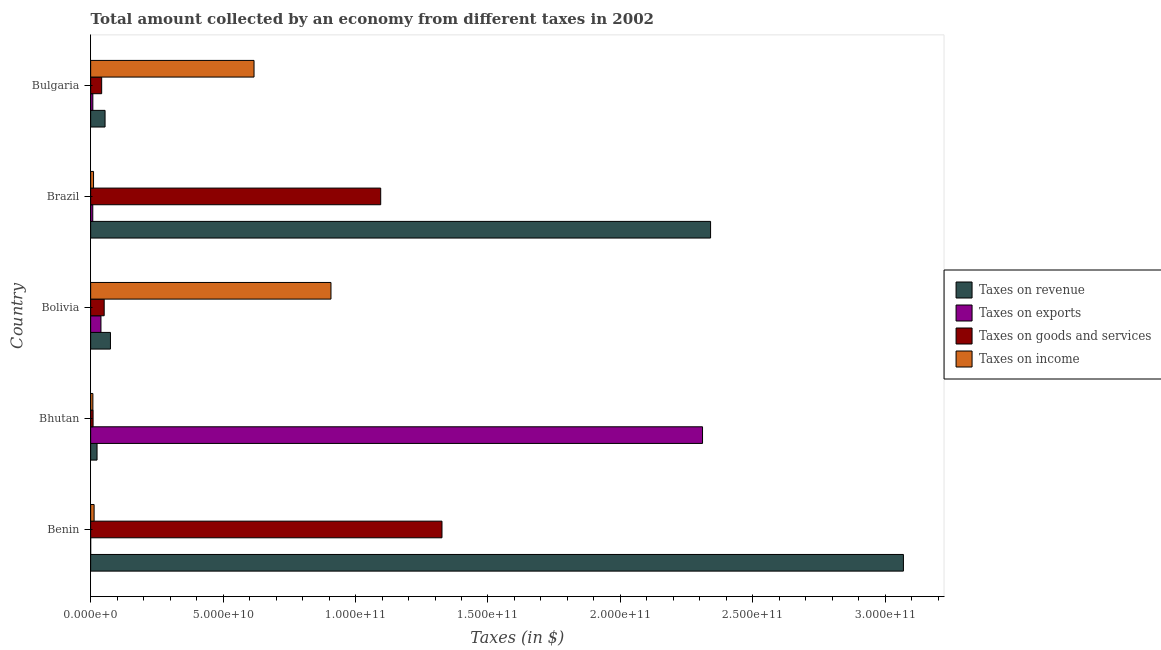How many different coloured bars are there?
Give a very brief answer. 4. How many groups of bars are there?
Your answer should be compact. 5. Are the number of bars on each tick of the Y-axis equal?
Make the answer very short. Yes. How many bars are there on the 1st tick from the top?
Keep it short and to the point. 4. What is the amount collected as tax on goods in Bhutan?
Provide a succinct answer. 9.15e+08. Across all countries, what is the maximum amount collected as tax on revenue?
Your answer should be very brief. 3.07e+11. Across all countries, what is the minimum amount collected as tax on exports?
Your answer should be compact. 6.36e+05. In which country was the amount collected as tax on revenue maximum?
Offer a very short reply. Benin. In which country was the amount collected as tax on revenue minimum?
Your answer should be compact. Bhutan. What is the total amount collected as tax on goods in the graph?
Your answer should be very brief. 2.52e+11. What is the difference between the amount collected as tax on goods in Benin and that in Brazil?
Offer a very short reply. 2.31e+1. What is the difference between the amount collected as tax on goods in Bulgaria and the amount collected as tax on revenue in Benin?
Provide a short and direct response. -3.03e+11. What is the average amount collected as tax on exports per country?
Make the answer very short. 4.73e+1. What is the difference between the amount collected as tax on income and amount collected as tax on goods in Bhutan?
Make the answer very short. -7.36e+07. In how many countries, is the amount collected as tax on income greater than 200000000000 $?
Offer a terse response. 0. What is the ratio of the amount collected as tax on exports in Bhutan to that in Bolivia?
Your response must be concise. 59.46. What is the difference between the highest and the second highest amount collected as tax on revenue?
Provide a succinct answer. 7.28e+1. What is the difference between the highest and the lowest amount collected as tax on revenue?
Your response must be concise. 3.04e+11. In how many countries, is the amount collected as tax on income greater than the average amount collected as tax on income taken over all countries?
Your answer should be compact. 2. What does the 1st bar from the top in Bolivia represents?
Ensure brevity in your answer.  Taxes on income. What does the 2nd bar from the bottom in Brazil represents?
Offer a very short reply. Taxes on exports. Is it the case that in every country, the sum of the amount collected as tax on revenue and amount collected as tax on exports is greater than the amount collected as tax on goods?
Your answer should be very brief. Yes. Are all the bars in the graph horizontal?
Keep it short and to the point. Yes. What is the difference between two consecutive major ticks on the X-axis?
Provide a succinct answer. 5.00e+1. Does the graph contain grids?
Make the answer very short. No. How many legend labels are there?
Your answer should be very brief. 4. What is the title of the graph?
Make the answer very short. Total amount collected by an economy from different taxes in 2002. Does "Periodicity assessment" appear as one of the legend labels in the graph?
Your answer should be compact. No. What is the label or title of the X-axis?
Offer a very short reply. Taxes (in $). What is the label or title of the Y-axis?
Your answer should be compact. Country. What is the Taxes (in $) of Taxes on revenue in Benin?
Provide a short and direct response. 3.07e+11. What is the Taxes (in $) of Taxes on exports in Benin?
Keep it short and to the point. 6.36e+05. What is the Taxes (in $) in Taxes on goods and services in Benin?
Provide a short and direct response. 1.33e+11. What is the Taxes (in $) in Taxes on income in Benin?
Your answer should be compact. 1.31e+09. What is the Taxes (in $) in Taxes on revenue in Bhutan?
Keep it short and to the point. 2.41e+09. What is the Taxes (in $) in Taxes on exports in Bhutan?
Provide a short and direct response. 2.31e+11. What is the Taxes (in $) of Taxes on goods and services in Bhutan?
Your answer should be very brief. 9.15e+08. What is the Taxes (in $) of Taxes on income in Bhutan?
Make the answer very short. 8.41e+08. What is the Taxes (in $) in Taxes on revenue in Bolivia?
Give a very brief answer. 7.47e+09. What is the Taxes (in $) in Taxes on exports in Bolivia?
Provide a short and direct response. 3.89e+09. What is the Taxes (in $) of Taxes on goods and services in Bolivia?
Offer a very short reply. 5.11e+09. What is the Taxes (in $) of Taxes on income in Bolivia?
Your response must be concise. 9.07e+1. What is the Taxes (in $) in Taxes on revenue in Brazil?
Keep it short and to the point. 2.34e+11. What is the Taxes (in $) in Taxes on exports in Brazil?
Give a very brief answer. 8.03e+08. What is the Taxes (in $) in Taxes on goods and services in Brazil?
Keep it short and to the point. 1.10e+11. What is the Taxes (in $) in Taxes on income in Brazil?
Your answer should be very brief. 1.09e+09. What is the Taxes (in $) in Taxes on revenue in Bulgaria?
Make the answer very short. 5.44e+09. What is the Taxes (in $) in Taxes on exports in Bulgaria?
Keep it short and to the point. 8.25e+08. What is the Taxes (in $) in Taxes on goods and services in Bulgaria?
Your answer should be very brief. 4.16e+09. What is the Taxes (in $) of Taxes on income in Bulgaria?
Your response must be concise. 6.17e+1. Across all countries, what is the maximum Taxes (in $) in Taxes on revenue?
Your answer should be compact. 3.07e+11. Across all countries, what is the maximum Taxes (in $) in Taxes on exports?
Offer a terse response. 2.31e+11. Across all countries, what is the maximum Taxes (in $) in Taxes on goods and services?
Give a very brief answer. 1.33e+11. Across all countries, what is the maximum Taxes (in $) in Taxes on income?
Give a very brief answer. 9.07e+1. Across all countries, what is the minimum Taxes (in $) in Taxes on revenue?
Your response must be concise. 2.41e+09. Across all countries, what is the minimum Taxes (in $) in Taxes on exports?
Your answer should be compact. 6.36e+05. Across all countries, what is the minimum Taxes (in $) in Taxes on goods and services?
Make the answer very short. 9.15e+08. Across all countries, what is the minimum Taxes (in $) in Taxes on income?
Your answer should be compact. 8.41e+08. What is the total Taxes (in $) of Taxes on revenue in the graph?
Make the answer very short. 5.56e+11. What is the total Taxes (in $) of Taxes on exports in the graph?
Provide a short and direct response. 2.37e+11. What is the total Taxes (in $) in Taxes on goods and services in the graph?
Your answer should be very brief. 2.52e+11. What is the total Taxes (in $) in Taxes on income in the graph?
Offer a terse response. 1.56e+11. What is the difference between the Taxes (in $) of Taxes on revenue in Benin and that in Bhutan?
Provide a short and direct response. 3.04e+11. What is the difference between the Taxes (in $) of Taxes on exports in Benin and that in Bhutan?
Make the answer very short. -2.31e+11. What is the difference between the Taxes (in $) of Taxes on goods and services in Benin and that in Bhutan?
Provide a succinct answer. 1.32e+11. What is the difference between the Taxes (in $) in Taxes on income in Benin and that in Bhutan?
Give a very brief answer. 4.64e+08. What is the difference between the Taxes (in $) of Taxes on revenue in Benin and that in Bolivia?
Ensure brevity in your answer.  2.99e+11. What is the difference between the Taxes (in $) in Taxes on exports in Benin and that in Bolivia?
Keep it short and to the point. -3.88e+09. What is the difference between the Taxes (in $) in Taxes on goods and services in Benin and that in Bolivia?
Make the answer very short. 1.28e+11. What is the difference between the Taxes (in $) of Taxes on income in Benin and that in Bolivia?
Your answer should be compact. -8.94e+1. What is the difference between the Taxes (in $) in Taxes on revenue in Benin and that in Brazil?
Offer a terse response. 7.28e+1. What is the difference between the Taxes (in $) in Taxes on exports in Benin and that in Brazil?
Provide a succinct answer. -8.02e+08. What is the difference between the Taxes (in $) of Taxes on goods and services in Benin and that in Brazil?
Provide a succinct answer. 2.31e+1. What is the difference between the Taxes (in $) in Taxes on income in Benin and that in Brazil?
Ensure brevity in your answer.  2.17e+08. What is the difference between the Taxes (in $) in Taxes on revenue in Benin and that in Bulgaria?
Keep it short and to the point. 3.01e+11. What is the difference between the Taxes (in $) of Taxes on exports in Benin and that in Bulgaria?
Your response must be concise. -8.25e+08. What is the difference between the Taxes (in $) in Taxes on goods and services in Benin and that in Bulgaria?
Make the answer very short. 1.28e+11. What is the difference between the Taxes (in $) in Taxes on income in Benin and that in Bulgaria?
Your response must be concise. -6.04e+1. What is the difference between the Taxes (in $) in Taxes on revenue in Bhutan and that in Bolivia?
Provide a short and direct response. -5.06e+09. What is the difference between the Taxes (in $) in Taxes on exports in Bhutan and that in Bolivia?
Make the answer very short. 2.27e+11. What is the difference between the Taxes (in $) of Taxes on goods and services in Bhutan and that in Bolivia?
Your answer should be compact. -4.19e+09. What is the difference between the Taxes (in $) in Taxes on income in Bhutan and that in Bolivia?
Offer a very short reply. -8.99e+1. What is the difference between the Taxes (in $) of Taxes on revenue in Bhutan and that in Brazil?
Your response must be concise. -2.32e+11. What is the difference between the Taxes (in $) of Taxes on exports in Bhutan and that in Brazil?
Your answer should be compact. 2.30e+11. What is the difference between the Taxes (in $) of Taxes on goods and services in Bhutan and that in Brazil?
Your answer should be very brief. -1.09e+11. What is the difference between the Taxes (in $) in Taxes on income in Bhutan and that in Brazil?
Your response must be concise. -2.47e+08. What is the difference between the Taxes (in $) in Taxes on revenue in Bhutan and that in Bulgaria?
Your response must be concise. -3.02e+09. What is the difference between the Taxes (in $) in Taxes on exports in Bhutan and that in Bulgaria?
Your response must be concise. 2.30e+11. What is the difference between the Taxes (in $) of Taxes on goods and services in Bhutan and that in Bulgaria?
Offer a terse response. -3.24e+09. What is the difference between the Taxes (in $) of Taxes on income in Bhutan and that in Bulgaria?
Your answer should be very brief. -6.08e+1. What is the difference between the Taxes (in $) in Taxes on revenue in Bolivia and that in Brazil?
Offer a terse response. -2.27e+11. What is the difference between the Taxes (in $) in Taxes on exports in Bolivia and that in Brazil?
Offer a terse response. 3.08e+09. What is the difference between the Taxes (in $) of Taxes on goods and services in Bolivia and that in Brazil?
Provide a short and direct response. -1.04e+11. What is the difference between the Taxes (in $) in Taxes on income in Bolivia and that in Brazil?
Keep it short and to the point. 8.96e+1. What is the difference between the Taxes (in $) of Taxes on revenue in Bolivia and that in Bulgaria?
Ensure brevity in your answer.  2.03e+09. What is the difference between the Taxes (in $) in Taxes on exports in Bolivia and that in Bulgaria?
Keep it short and to the point. 3.06e+09. What is the difference between the Taxes (in $) of Taxes on goods and services in Bolivia and that in Bulgaria?
Your answer should be compact. 9.51e+08. What is the difference between the Taxes (in $) in Taxes on income in Bolivia and that in Bulgaria?
Give a very brief answer. 2.90e+1. What is the difference between the Taxes (in $) of Taxes on revenue in Brazil and that in Bulgaria?
Offer a very short reply. 2.29e+11. What is the difference between the Taxes (in $) in Taxes on exports in Brazil and that in Bulgaria?
Give a very brief answer. -2.22e+07. What is the difference between the Taxes (in $) of Taxes on goods and services in Brazil and that in Bulgaria?
Make the answer very short. 1.05e+11. What is the difference between the Taxes (in $) of Taxes on income in Brazil and that in Bulgaria?
Your response must be concise. -6.06e+1. What is the difference between the Taxes (in $) of Taxes on revenue in Benin and the Taxes (in $) of Taxes on exports in Bhutan?
Your response must be concise. 7.58e+1. What is the difference between the Taxes (in $) in Taxes on revenue in Benin and the Taxes (in $) in Taxes on goods and services in Bhutan?
Your answer should be compact. 3.06e+11. What is the difference between the Taxes (in $) in Taxes on revenue in Benin and the Taxes (in $) in Taxes on income in Bhutan?
Provide a short and direct response. 3.06e+11. What is the difference between the Taxes (in $) of Taxes on exports in Benin and the Taxes (in $) of Taxes on goods and services in Bhutan?
Keep it short and to the point. -9.14e+08. What is the difference between the Taxes (in $) in Taxes on exports in Benin and the Taxes (in $) in Taxes on income in Bhutan?
Your answer should be compact. -8.41e+08. What is the difference between the Taxes (in $) of Taxes on goods and services in Benin and the Taxes (in $) of Taxes on income in Bhutan?
Keep it short and to the point. 1.32e+11. What is the difference between the Taxes (in $) in Taxes on revenue in Benin and the Taxes (in $) in Taxes on exports in Bolivia?
Ensure brevity in your answer.  3.03e+11. What is the difference between the Taxes (in $) in Taxes on revenue in Benin and the Taxes (in $) in Taxes on goods and services in Bolivia?
Ensure brevity in your answer.  3.02e+11. What is the difference between the Taxes (in $) in Taxes on revenue in Benin and the Taxes (in $) in Taxes on income in Bolivia?
Your response must be concise. 2.16e+11. What is the difference between the Taxes (in $) in Taxes on exports in Benin and the Taxes (in $) in Taxes on goods and services in Bolivia?
Provide a succinct answer. -5.11e+09. What is the difference between the Taxes (in $) in Taxes on exports in Benin and the Taxes (in $) in Taxes on income in Bolivia?
Provide a short and direct response. -9.07e+1. What is the difference between the Taxes (in $) of Taxes on goods and services in Benin and the Taxes (in $) of Taxes on income in Bolivia?
Offer a terse response. 4.19e+1. What is the difference between the Taxes (in $) of Taxes on revenue in Benin and the Taxes (in $) of Taxes on exports in Brazil?
Offer a very short reply. 3.06e+11. What is the difference between the Taxes (in $) in Taxes on revenue in Benin and the Taxes (in $) in Taxes on goods and services in Brazil?
Offer a very short reply. 1.97e+11. What is the difference between the Taxes (in $) in Taxes on revenue in Benin and the Taxes (in $) in Taxes on income in Brazil?
Your response must be concise. 3.06e+11. What is the difference between the Taxes (in $) of Taxes on exports in Benin and the Taxes (in $) of Taxes on goods and services in Brazil?
Offer a very short reply. -1.10e+11. What is the difference between the Taxes (in $) in Taxes on exports in Benin and the Taxes (in $) in Taxes on income in Brazil?
Your response must be concise. -1.09e+09. What is the difference between the Taxes (in $) of Taxes on goods and services in Benin and the Taxes (in $) of Taxes on income in Brazil?
Provide a short and direct response. 1.32e+11. What is the difference between the Taxes (in $) of Taxes on revenue in Benin and the Taxes (in $) of Taxes on exports in Bulgaria?
Give a very brief answer. 3.06e+11. What is the difference between the Taxes (in $) of Taxes on revenue in Benin and the Taxes (in $) of Taxes on goods and services in Bulgaria?
Keep it short and to the point. 3.03e+11. What is the difference between the Taxes (in $) of Taxes on revenue in Benin and the Taxes (in $) of Taxes on income in Bulgaria?
Ensure brevity in your answer.  2.45e+11. What is the difference between the Taxes (in $) in Taxes on exports in Benin and the Taxes (in $) in Taxes on goods and services in Bulgaria?
Your answer should be very brief. -4.16e+09. What is the difference between the Taxes (in $) in Taxes on exports in Benin and the Taxes (in $) in Taxes on income in Bulgaria?
Ensure brevity in your answer.  -6.17e+1. What is the difference between the Taxes (in $) in Taxes on goods and services in Benin and the Taxes (in $) in Taxes on income in Bulgaria?
Provide a succinct answer. 7.10e+1. What is the difference between the Taxes (in $) in Taxes on revenue in Bhutan and the Taxes (in $) in Taxes on exports in Bolivia?
Your answer should be compact. -1.47e+09. What is the difference between the Taxes (in $) in Taxes on revenue in Bhutan and the Taxes (in $) in Taxes on goods and services in Bolivia?
Keep it short and to the point. -2.69e+09. What is the difference between the Taxes (in $) in Taxes on revenue in Bhutan and the Taxes (in $) in Taxes on income in Bolivia?
Offer a terse response. -8.83e+1. What is the difference between the Taxes (in $) of Taxes on exports in Bhutan and the Taxes (in $) of Taxes on goods and services in Bolivia?
Your answer should be compact. 2.26e+11. What is the difference between the Taxes (in $) in Taxes on exports in Bhutan and the Taxes (in $) in Taxes on income in Bolivia?
Keep it short and to the point. 1.40e+11. What is the difference between the Taxes (in $) of Taxes on goods and services in Bhutan and the Taxes (in $) of Taxes on income in Bolivia?
Ensure brevity in your answer.  -8.98e+1. What is the difference between the Taxes (in $) of Taxes on revenue in Bhutan and the Taxes (in $) of Taxes on exports in Brazil?
Make the answer very short. 1.61e+09. What is the difference between the Taxes (in $) in Taxes on revenue in Bhutan and the Taxes (in $) in Taxes on goods and services in Brazil?
Your answer should be very brief. -1.07e+11. What is the difference between the Taxes (in $) of Taxes on revenue in Bhutan and the Taxes (in $) of Taxes on income in Brazil?
Ensure brevity in your answer.  1.33e+09. What is the difference between the Taxes (in $) of Taxes on exports in Bhutan and the Taxes (in $) of Taxes on goods and services in Brazil?
Your response must be concise. 1.21e+11. What is the difference between the Taxes (in $) of Taxes on exports in Bhutan and the Taxes (in $) of Taxes on income in Brazil?
Your answer should be very brief. 2.30e+11. What is the difference between the Taxes (in $) in Taxes on goods and services in Bhutan and the Taxes (in $) in Taxes on income in Brazil?
Ensure brevity in your answer.  -1.73e+08. What is the difference between the Taxes (in $) of Taxes on revenue in Bhutan and the Taxes (in $) of Taxes on exports in Bulgaria?
Your response must be concise. 1.59e+09. What is the difference between the Taxes (in $) of Taxes on revenue in Bhutan and the Taxes (in $) of Taxes on goods and services in Bulgaria?
Your answer should be very brief. -1.74e+09. What is the difference between the Taxes (in $) in Taxes on revenue in Bhutan and the Taxes (in $) in Taxes on income in Bulgaria?
Your answer should be compact. -5.93e+1. What is the difference between the Taxes (in $) in Taxes on exports in Bhutan and the Taxes (in $) in Taxes on goods and services in Bulgaria?
Your answer should be compact. 2.27e+11. What is the difference between the Taxes (in $) in Taxes on exports in Bhutan and the Taxes (in $) in Taxes on income in Bulgaria?
Offer a terse response. 1.69e+11. What is the difference between the Taxes (in $) of Taxes on goods and services in Bhutan and the Taxes (in $) of Taxes on income in Bulgaria?
Make the answer very short. -6.08e+1. What is the difference between the Taxes (in $) of Taxes on revenue in Bolivia and the Taxes (in $) of Taxes on exports in Brazil?
Provide a succinct answer. 6.67e+09. What is the difference between the Taxes (in $) of Taxes on revenue in Bolivia and the Taxes (in $) of Taxes on goods and services in Brazil?
Ensure brevity in your answer.  -1.02e+11. What is the difference between the Taxes (in $) in Taxes on revenue in Bolivia and the Taxes (in $) in Taxes on income in Brazil?
Provide a short and direct response. 6.38e+09. What is the difference between the Taxes (in $) of Taxes on exports in Bolivia and the Taxes (in $) of Taxes on goods and services in Brazil?
Your answer should be very brief. -1.06e+11. What is the difference between the Taxes (in $) in Taxes on exports in Bolivia and the Taxes (in $) in Taxes on income in Brazil?
Offer a terse response. 2.80e+09. What is the difference between the Taxes (in $) of Taxes on goods and services in Bolivia and the Taxes (in $) of Taxes on income in Brazil?
Your answer should be compact. 4.02e+09. What is the difference between the Taxes (in $) in Taxes on revenue in Bolivia and the Taxes (in $) in Taxes on exports in Bulgaria?
Give a very brief answer. 6.65e+09. What is the difference between the Taxes (in $) of Taxes on revenue in Bolivia and the Taxes (in $) of Taxes on goods and services in Bulgaria?
Offer a very short reply. 3.31e+09. What is the difference between the Taxes (in $) of Taxes on revenue in Bolivia and the Taxes (in $) of Taxes on income in Bulgaria?
Offer a very short reply. -5.42e+1. What is the difference between the Taxes (in $) of Taxes on exports in Bolivia and the Taxes (in $) of Taxes on goods and services in Bulgaria?
Provide a short and direct response. -2.74e+08. What is the difference between the Taxes (in $) in Taxes on exports in Bolivia and the Taxes (in $) in Taxes on income in Bulgaria?
Your answer should be very brief. -5.78e+1. What is the difference between the Taxes (in $) of Taxes on goods and services in Bolivia and the Taxes (in $) of Taxes on income in Bulgaria?
Provide a short and direct response. -5.66e+1. What is the difference between the Taxes (in $) of Taxes on revenue in Brazil and the Taxes (in $) of Taxes on exports in Bulgaria?
Your answer should be very brief. 2.33e+11. What is the difference between the Taxes (in $) of Taxes on revenue in Brazil and the Taxes (in $) of Taxes on goods and services in Bulgaria?
Your answer should be very brief. 2.30e+11. What is the difference between the Taxes (in $) in Taxes on revenue in Brazil and the Taxes (in $) in Taxes on income in Bulgaria?
Offer a terse response. 1.72e+11. What is the difference between the Taxes (in $) in Taxes on exports in Brazil and the Taxes (in $) in Taxes on goods and services in Bulgaria?
Offer a very short reply. -3.36e+09. What is the difference between the Taxes (in $) of Taxes on exports in Brazil and the Taxes (in $) of Taxes on income in Bulgaria?
Offer a terse response. -6.09e+1. What is the difference between the Taxes (in $) in Taxes on goods and services in Brazil and the Taxes (in $) in Taxes on income in Bulgaria?
Make the answer very short. 4.78e+1. What is the average Taxes (in $) in Taxes on revenue per country?
Offer a very short reply. 1.11e+11. What is the average Taxes (in $) in Taxes on exports per country?
Your answer should be compact. 4.73e+1. What is the average Taxes (in $) of Taxes on goods and services per country?
Your answer should be very brief. 5.05e+1. What is the average Taxes (in $) in Taxes on income per country?
Your answer should be very brief. 3.11e+1. What is the difference between the Taxes (in $) of Taxes on revenue and Taxes (in $) of Taxes on exports in Benin?
Give a very brief answer. 3.07e+11. What is the difference between the Taxes (in $) in Taxes on revenue and Taxes (in $) in Taxes on goods and services in Benin?
Ensure brevity in your answer.  1.74e+11. What is the difference between the Taxes (in $) of Taxes on revenue and Taxes (in $) of Taxes on income in Benin?
Ensure brevity in your answer.  3.06e+11. What is the difference between the Taxes (in $) in Taxes on exports and Taxes (in $) in Taxes on goods and services in Benin?
Offer a terse response. -1.33e+11. What is the difference between the Taxes (in $) of Taxes on exports and Taxes (in $) of Taxes on income in Benin?
Your answer should be compact. -1.30e+09. What is the difference between the Taxes (in $) in Taxes on goods and services and Taxes (in $) in Taxes on income in Benin?
Give a very brief answer. 1.31e+11. What is the difference between the Taxes (in $) in Taxes on revenue and Taxes (in $) in Taxes on exports in Bhutan?
Keep it short and to the point. -2.29e+11. What is the difference between the Taxes (in $) of Taxes on revenue and Taxes (in $) of Taxes on goods and services in Bhutan?
Give a very brief answer. 1.50e+09. What is the difference between the Taxes (in $) in Taxes on revenue and Taxes (in $) in Taxes on income in Bhutan?
Your answer should be compact. 1.57e+09. What is the difference between the Taxes (in $) of Taxes on exports and Taxes (in $) of Taxes on goods and services in Bhutan?
Your answer should be compact. 2.30e+11. What is the difference between the Taxes (in $) in Taxes on exports and Taxes (in $) in Taxes on income in Bhutan?
Give a very brief answer. 2.30e+11. What is the difference between the Taxes (in $) in Taxes on goods and services and Taxes (in $) in Taxes on income in Bhutan?
Provide a succinct answer. 7.36e+07. What is the difference between the Taxes (in $) of Taxes on revenue and Taxes (in $) of Taxes on exports in Bolivia?
Make the answer very short. 3.59e+09. What is the difference between the Taxes (in $) of Taxes on revenue and Taxes (in $) of Taxes on goods and services in Bolivia?
Your answer should be very brief. 2.36e+09. What is the difference between the Taxes (in $) of Taxes on revenue and Taxes (in $) of Taxes on income in Bolivia?
Offer a terse response. -8.33e+1. What is the difference between the Taxes (in $) of Taxes on exports and Taxes (in $) of Taxes on goods and services in Bolivia?
Your answer should be very brief. -1.22e+09. What is the difference between the Taxes (in $) of Taxes on exports and Taxes (in $) of Taxes on income in Bolivia?
Your response must be concise. -8.68e+1. What is the difference between the Taxes (in $) of Taxes on goods and services and Taxes (in $) of Taxes on income in Bolivia?
Provide a succinct answer. -8.56e+1. What is the difference between the Taxes (in $) in Taxes on revenue and Taxes (in $) in Taxes on exports in Brazil?
Your answer should be compact. 2.33e+11. What is the difference between the Taxes (in $) of Taxes on revenue and Taxes (in $) of Taxes on goods and services in Brazil?
Offer a terse response. 1.25e+11. What is the difference between the Taxes (in $) in Taxes on revenue and Taxes (in $) in Taxes on income in Brazil?
Keep it short and to the point. 2.33e+11. What is the difference between the Taxes (in $) in Taxes on exports and Taxes (in $) in Taxes on goods and services in Brazil?
Your answer should be compact. -1.09e+11. What is the difference between the Taxes (in $) of Taxes on exports and Taxes (in $) of Taxes on income in Brazil?
Give a very brief answer. -2.85e+08. What is the difference between the Taxes (in $) in Taxes on goods and services and Taxes (in $) in Taxes on income in Brazil?
Give a very brief answer. 1.08e+11. What is the difference between the Taxes (in $) in Taxes on revenue and Taxes (in $) in Taxes on exports in Bulgaria?
Ensure brevity in your answer.  4.61e+09. What is the difference between the Taxes (in $) of Taxes on revenue and Taxes (in $) of Taxes on goods and services in Bulgaria?
Provide a short and direct response. 1.28e+09. What is the difference between the Taxes (in $) in Taxes on revenue and Taxes (in $) in Taxes on income in Bulgaria?
Your answer should be very brief. -5.62e+1. What is the difference between the Taxes (in $) of Taxes on exports and Taxes (in $) of Taxes on goods and services in Bulgaria?
Offer a terse response. -3.33e+09. What is the difference between the Taxes (in $) in Taxes on exports and Taxes (in $) in Taxes on income in Bulgaria?
Ensure brevity in your answer.  -6.09e+1. What is the difference between the Taxes (in $) in Taxes on goods and services and Taxes (in $) in Taxes on income in Bulgaria?
Give a very brief answer. -5.75e+1. What is the ratio of the Taxes (in $) of Taxes on revenue in Benin to that in Bhutan?
Offer a terse response. 127.08. What is the ratio of the Taxes (in $) in Taxes on exports in Benin to that in Bhutan?
Provide a succinct answer. 0. What is the ratio of the Taxes (in $) in Taxes on goods and services in Benin to that in Bhutan?
Give a very brief answer. 144.95. What is the ratio of the Taxes (in $) of Taxes on income in Benin to that in Bhutan?
Your answer should be compact. 1.55. What is the ratio of the Taxes (in $) of Taxes on revenue in Benin to that in Bolivia?
Make the answer very short. 41.06. What is the ratio of the Taxes (in $) in Taxes on goods and services in Benin to that in Bolivia?
Your answer should be very brief. 25.96. What is the ratio of the Taxes (in $) in Taxes on income in Benin to that in Bolivia?
Your response must be concise. 0.01. What is the ratio of the Taxes (in $) of Taxes on revenue in Benin to that in Brazil?
Offer a terse response. 1.31. What is the ratio of the Taxes (in $) of Taxes on exports in Benin to that in Brazil?
Your response must be concise. 0. What is the ratio of the Taxes (in $) of Taxes on goods and services in Benin to that in Brazil?
Offer a terse response. 1.21. What is the ratio of the Taxes (in $) of Taxes on income in Benin to that in Brazil?
Your answer should be compact. 1.2. What is the ratio of the Taxes (in $) of Taxes on revenue in Benin to that in Bulgaria?
Provide a succinct answer. 56.42. What is the ratio of the Taxes (in $) in Taxes on exports in Benin to that in Bulgaria?
Offer a terse response. 0. What is the ratio of the Taxes (in $) in Taxes on goods and services in Benin to that in Bulgaria?
Provide a succinct answer. 31.89. What is the ratio of the Taxes (in $) in Taxes on income in Benin to that in Bulgaria?
Offer a very short reply. 0.02. What is the ratio of the Taxes (in $) in Taxes on revenue in Bhutan to that in Bolivia?
Offer a very short reply. 0.32. What is the ratio of the Taxes (in $) of Taxes on exports in Bhutan to that in Bolivia?
Offer a very short reply. 59.46. What is the ratio of the Taxes (in $) of Taxes on goods and services in Bhutan to that in Bolivia?
Offer a terse response. 0.18. What is the ratio of the Taxes (in $) in Taxes on income in Bhutan to that in Bolivia?
Offer a very short reply. 0.01. What is the ratio of the Taxes (in $) in Taxes on revenue in Bhutan to that in Brazil?
Provide a short and direct response. 0.01. What is the ratio of the Taxes (in $) of Taxes on exports in Bhutan to that in Brazil?
Give a very brief answer. 287.67. What is the ratio of the Taxes (in $) of Taxes on goods and services in Bhutan to that in Brazil?
Provide a succinct answer. 0.01. What is the ratio of the Taxes (in $) of Taxes on income in Bhutan to that in Brazil?
Make the answer very short. 0.77. What is the ratio of the Taxes (in $) of Taxes on revenue in Bhutan to that in Bulgaria?
Give a very brief answer. 0.44. What is the ratio of the Taxes (in $) of Taxes on exports in Bhutan to that in Bulgaria?
Provide a succinct answer. 279.93. What is the ratio of the Taxes (in $) in Taxes on goods and services in Bhutan to that in Bulgaria?
Ensure brevity in your answer.  0.22. What is the ratio of the Taxes (in $) in Taxes on income in Bhutan to that in Bulgaria?
Give a very brief answer. 0.01. What is the ratio of the Taxes (in $) of Taxes on revenue in Bolivia to that in Brazil?
Offer a terse response. 0.03. What is the ratio of the Taxes (in $) of Taxes on exports in Bolivia to that in Brazil?
Your answer should be compact. 4.84. What is the ratio of the Taxes (in $) in Taxes on goods and services in Bolivia to that in Brazil?
Ensure brevity in your answer.  0.05. What is the ratio of the Taxes (in $) in Taxes on income in Bolivia to that in Brazil?
Keep it short and to the point. 83.37. What is the ratio of the Taxes (in $) of Taxes on revenue in Bolivia to that in Bulgaria?
Ensure brevity in your answer.  1.37. What is the ratio of the Taxes (in $) of Taxes on exports in Bolivia to that in Bulgaria?
Give a very brief answer. 4.71. What is the ratio of the Taxes (in $) in Taxes on goods and services in Bolivia to that in Bulgaria?
Make the answer very short. 1.23. What is the ratio of the Taxes (in $) in Taxes on income in Bolivia to that in Bulgaria?
Provide a succinct answer. 1.47. What is the ratio of the Taxes (in $) of Taxes on revenue in Brazil to that in Bulgaria?
Ensure brevity in your answer.  43.03. What is the ratio of the Taxes (in $) in Taxes on exports in Brazil to that in Bulgaria?
Your answer should be compact. 0.97. What is the ratio of the Taxes (in $) in Taxes on goods and services in Brazil to that in Bulgaria?
Provide a short and direct response. 26.33. What is the ratio of the Taxes (in $) in Taxes on income in Brazil to that in Bulgaria?
Your response must be concise. 0.02. What is the difference between the highest and the second highest Taxes (in $) in Taxes on revenue?
Keep it short and to the point. 7.28e+1. What is the difference between the highest and the second highest Taxes (in $) in Taxes on exports?
Offer a terse response. 2.27e+11. What is the difference between the highest and the second highest Taxes (in $) of Taxes on goods and services?
Give a very brief answer. 2.31e+1. What is the difference between the highest and the second highest Taxes (in $) in Taxes on income?
Give a very brief answer. 2.90e+1. What is the difference between the highest and the lowest Taxes (in $) in Taxes on revenue?
Provide a succinct answer. 3.04e+11. What is the difference between the highest and the lowest Taxes (in $) in Taxes on exports?
Give a very brief answer. 2.31e+11. What is the difference between the highest and the lowest Taxes (in $) in Taxes on goods and services?
Make the answer very short. 1.32e+11. What is the difference between the highest and the lowest Taxes (in $) in Taxes on income?
Ensure brevity in your answer.  8.99e+1. 